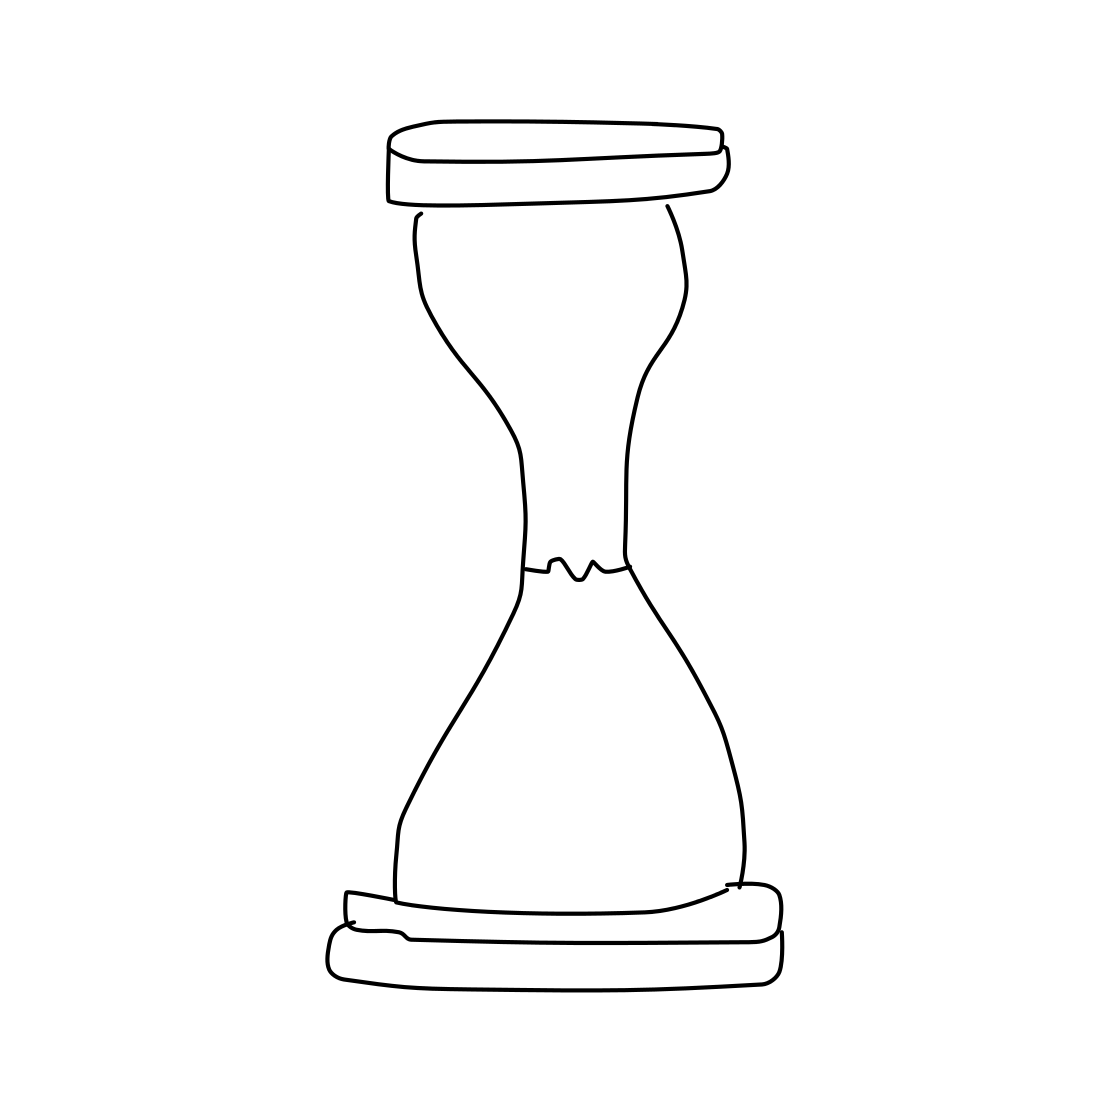Could you use this drawing in any practical way? As a simple line drawing, this hourglass could be used as a template for crafting projects, as an icon in graphic design, or as an educational illustration of an hourglass. Is the hourglass accurate for educational purposes? With its clear depiction of the basic structure of an hourglass, this drawing could be used to educate on the components and the principle of how an hourglass measures time. 